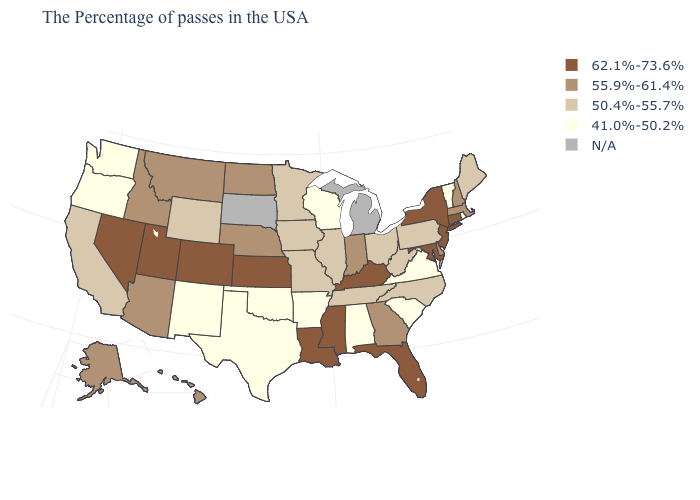Does Oklahoma have the highest value in the USA?
Concise answer only. No. Does the map have missing data?
Write a very short answer. Yes. Name the states that have a value in the range 50.4%-55.7%?
Quick response, please. Maine, Pennsylvania, North Carolina, West Virginia, Ohio, Tennessee, Illinois, Missouri, Minnesota, Iowa, Wyoming, California. What is the lowest value in states that border Wyoming?
Be succinct. 55.9%-61.4%. What is the value of South Carolina?
Write a very short answer. 41.0%-50.2%. Name the states that have a value in the range N/A?
Concise answer only. Michigan, South Dakota. Name the states that have a value in the range 50.4%-55.7%?
Write a very short answer. Maine, Pennsylvania, North Carolina, West Virginia, Ohio, Tennessee, Illinois, Missouri, Minnesota, Iowa, Wyoming, California. Does Mississippi have the lowest value in the USA?
Keep it brief. No. What is the value of North Dakota?
Answer briefly. 55.9%-61.4%. Does the map have missing data?
Be succinct. Yes. What is the value of South Carolina?
Give a very brief answer. 41.0%-50.2%. Does Kansas have the highest value in the MidWest?
Be succinct. Yes. Among the states that border Louisiana , does Mississippi have the lowest value?
Answer briefly. No. What is the lowest value in the Northeast?
Quick response, please. 41.0%-50.2%. 